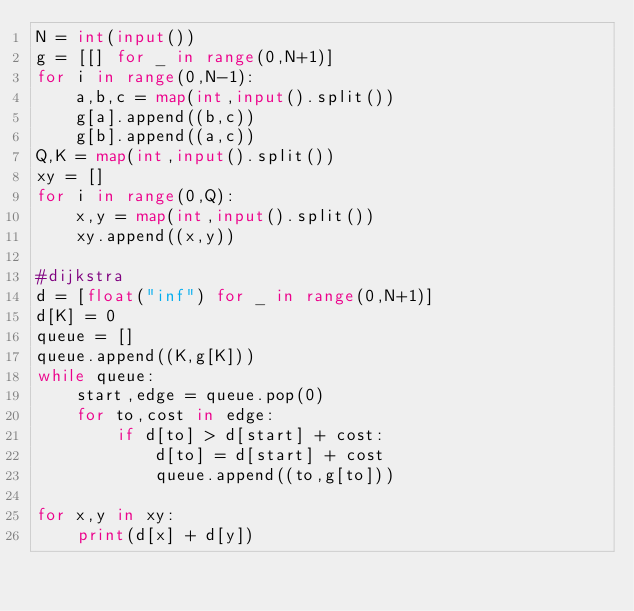Convert code to text. <code><loc_0><loc_0><loc_500><loc_500><_Python_>N = int(input())
g = [[] for _ in range(0,N+1)]
for i in range(0,N-1):
    a,b,c = map(int,input().split())
    g[a].append((b,c))
    g[b].append((a,c))
Q,K = map(int,input().split())
xy = []
for i in range(0,Q):
    x,y = map(int,input().split())
    xy.append((x,y))

#dijkstra
d = [float("inf") for _ in range(0,N+1)]
d[K] = 0
queue = []
queue.append((K,g[K]))
while queue:
    start,edge = queue.pop(0)
    for to,cost in edge:
        if d[to] > d[start] + cost:
            d[to] = d[start] + cost
            queue.append((to,g[to]))

for x,y in xy:
    print(d[x] + d[y])
</code> 